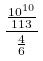Convert formula to latex. <formula><loc_0><loc_0><loc_500><loc_500>\frac { \frac { 1 0 ^ { 1 0 } } { 1 1 3 } } { \frac { 4 } { 6 } }</formula> 